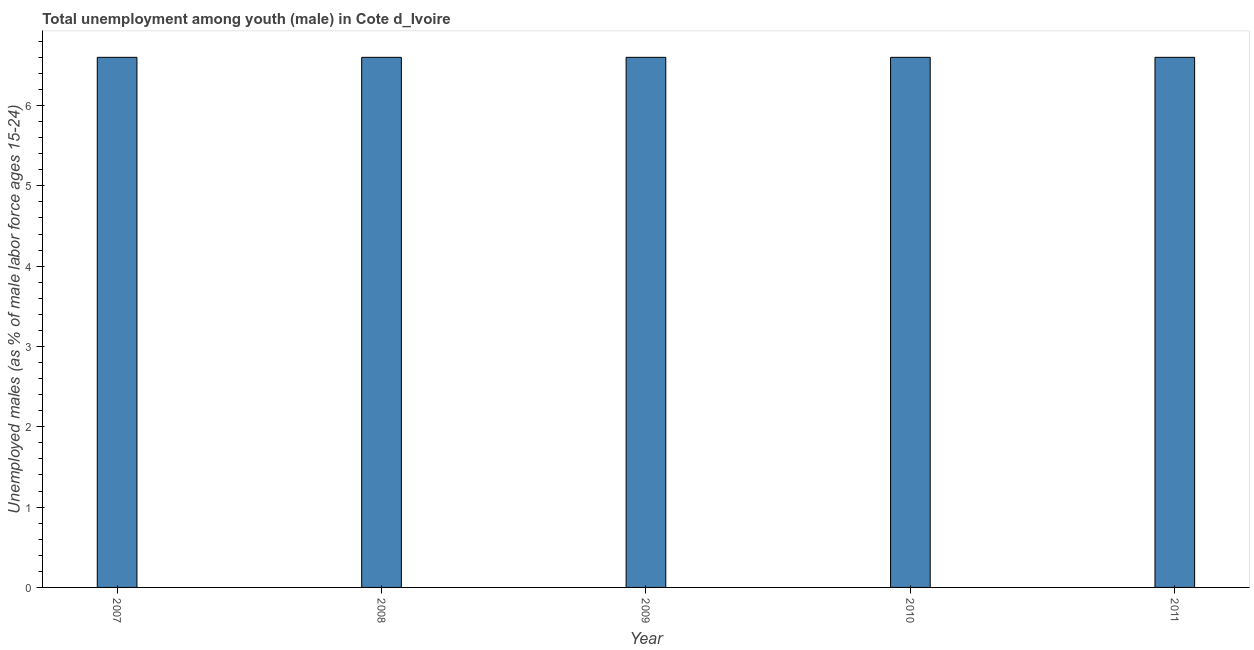Does the graph contain any zero values?
Provide a succinct answer. No. What is the title of the graph?
Provide a short and direct response. Total unemployment among youth (male) in Cote d_Ivoire. What is the label or title of the Y-axis?
Offer a very short reply. Unemployed males (as % of male labor force ages 15-24). What is the unemployed male youth population in 2008?
Ensure brevity in your answer.  6.6. Across all years, what is the maximum unemployed male youth population?
Provide a short and direct response. 6.6. Across all years, what is the minimum unemployed male youth population?
Provide a short and direct response. 6.6. In which year was the unemployed male youth population maximum?
Give a very brief answer. 2007. What is the sum of the unemployed male youth population?
Ensure brevity in your answer.  33. What is the average unemployed male youth population per year?
Offer a terse response. 6.6. What is the median unemployed male youth population?
Offer a very short reply. 6.6. Do a majority of the years between 2007 and 2010 (inclusive) have unemployed male youth population greater than 1 %?
Offer a terse response. Yes. What is the difference between the highest and the second highest unemployed male youth population?
Your answer should be very brief. 0. In how many years, is the unemployed male youth population greater than the average unemployed male youth population taken over all years?
Make the answer very short. 0. What is the Unemployed males (as % of male labor force ages 15-24) of 2007?
Offer a very short reply. 6.6. What is the Unemployed males (as % of male labor force ages 15-24) of 2008?
Offer a very short reply. 6.6. What is the Unemployed males (as % of male labor force ages 15-24) of 2009?
Keep it short and to the point. 6.6. What is the Unemployed males (as % of male labor force ages 15-24) in 2010?
Provide a succinct answer. 6.6. What is the Unemployed males (as % of male labor force ages 15-24) in 2011?
Provide a succinct answer. 6.6. What is the difference between the Unemployed males (as % of male labor force ages 15-24) in 2007 and 2010?
Your answer should be compact. 0. What is the difference between the Unemployed males (as % of male labor force ages 15-24) in 2008 and 2010?
Keep it short and to the point. 0. What is the difference between the Unemployed males (as % of male labor force ages 15-24) in 2008 and 2011?
Offer a terse response. 0. What is the difference between the Unemployed males (as % of male labor force ages 15-24) in 2009 and 2010?
Make the answer very short. 0. What is the difference between the Unemployed males (as % of male labor force ages 15-24) in 2010 and 2011?
Offer a very short reply. 0. What is the ratio of the Unemployed males (as % of male labor force ages 15-24) in 2007 to that in 2008?
Provide a succinct answer. 1. What is the ratio of the Unemployed males (as % of male labor force ages 15-24) in 2007 to that in 2011?
Keep it short and to the point. 1. What is the ratio of the Unemployed males (as % of male labor force ages 15-24) in 2008 to that in 2011?
Provide a short and direct response. 1. What is the ratio of the Unemployed males (as % of male labor force ages 15-24) in 2009 to that in 2010?
Offer a very short reply. 1. What is the ratio of the Unemployed males (as % of male labor force ages 15-24) in 2009 to that in 2011?
Make the answer very short. 1. 